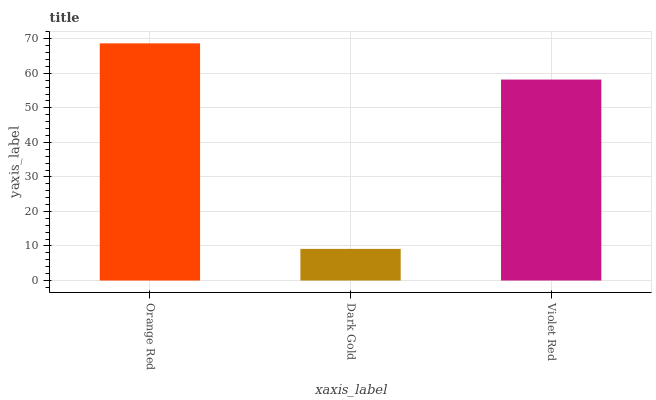Is Dark Gold the minimum?
Answer yes or no. Yes. Is Orange Red the maximum?
Answer yes or no. Yes. Is Violet Red the minimum?
Answer yes or no. No. Is Violet Red the maximum?
Answer yes or no. No. Is Violet Red greater than Dark Gold?
Answer yes or no. Yes. Is Dark Gold less than Violet Red?
Answer yes or no. Yes. Is Dark Gold greater than Violet Red?
Answer yes or no. No. Is Violet Red less than Dark Gold?
Answer yes or no. No. Is Violet Red the high median?
Answer yes or no. Yes. Is Violet Red the low median?
Answer yes or no. Yes. Is Orange Red the high median?
Answer yes or no. No. Is Orange Red the low median?
Answer yes or no. No. 